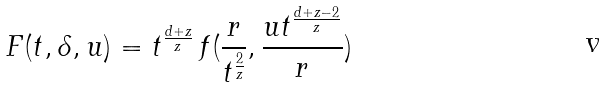<formula> <loc_0><loc_0><loc_500><loc_500>F ( t , \delta , u ) = t ^ { \frac { d + z } { z } } \, f ( \frac { r } { t ^ { \frac { 2 } { z } } } , \frac { u t ^ { \frac { d + z - 2 } { z } } } { r } )</formula> 